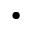Convert formula to latex. <formula><loc_0><loc_0><loc_500><loc_500>\bullet</formula> 